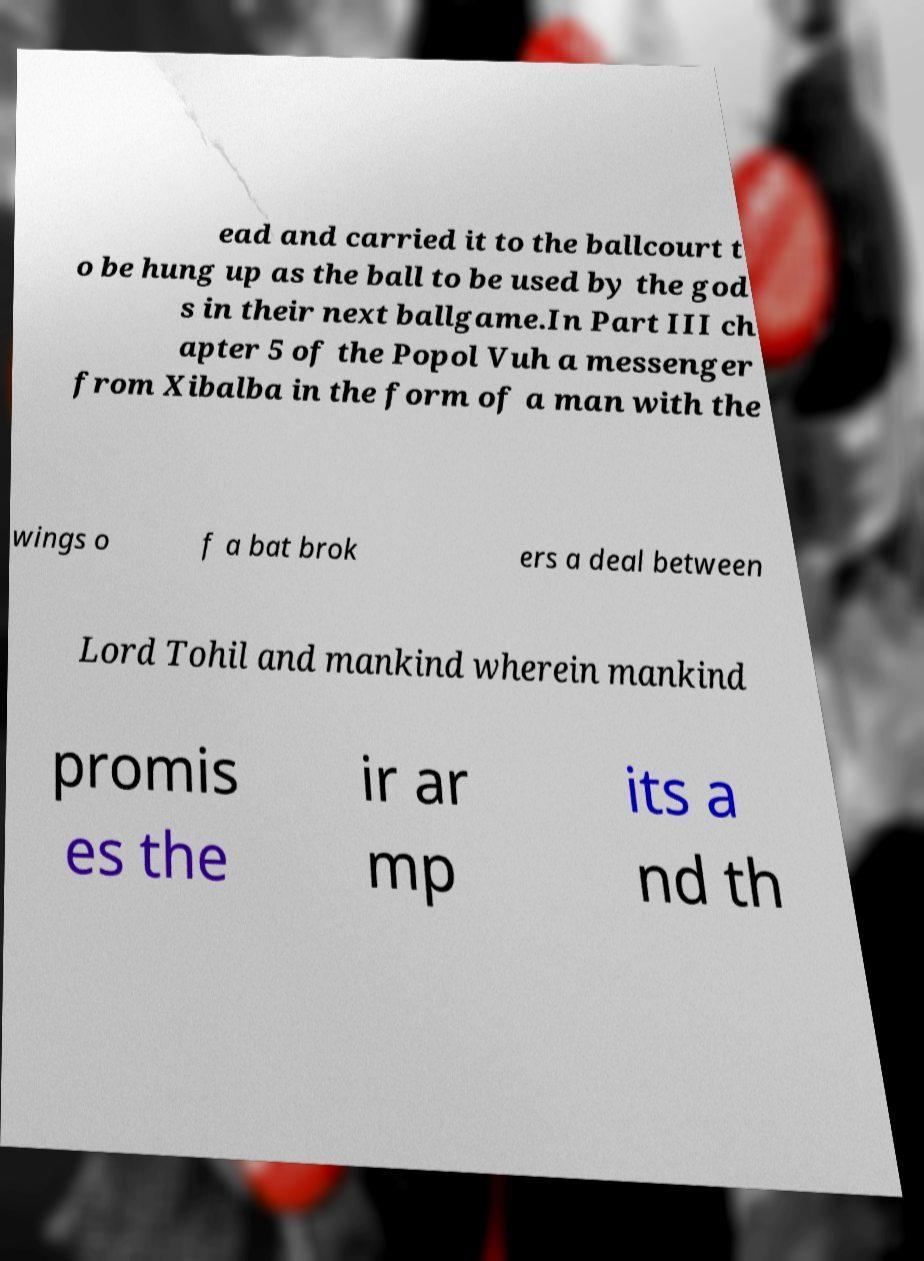I need the written content from this picture converted into text. Can you do that? ead and carried it to the ballcourt t o be hung up as the ball to be used by the god s in their next ballgame.In Part III ch apter 5 of the Popol Vuh a messenger from Xibalba in the form of a man with the wings o f a bat brok ers a deal between Lord Tohil and mankind wherein mankind promis es the ir ar mp its a nd th 